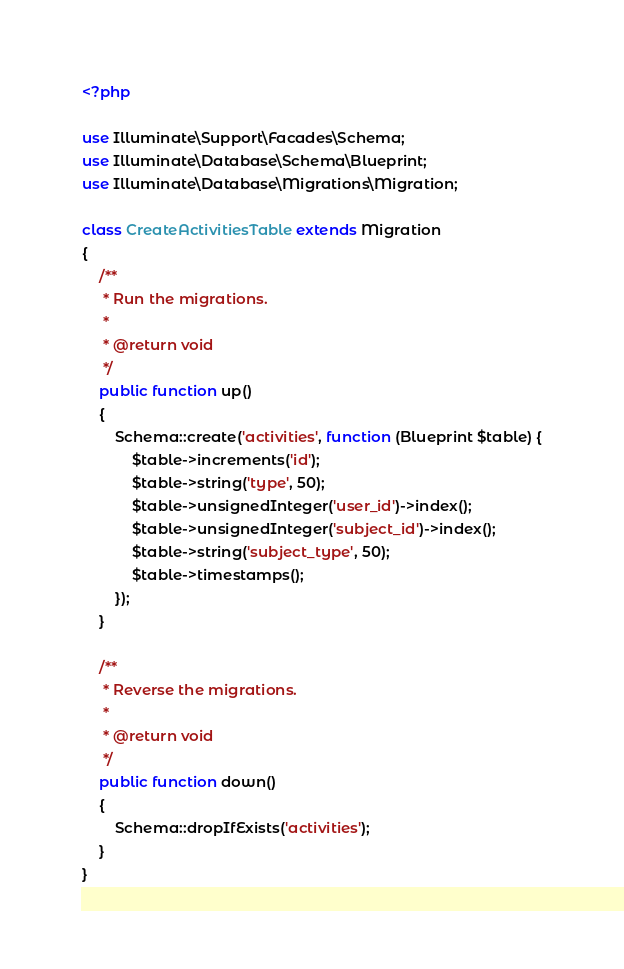<code> <loc_0><loc_0><loc_500><loc_500><_PHP_><?php

use Illuminate\Support\Facades\Schema;
use Illuminate\Database\Schema\Blueprint;
use Illuminate\Database\Migrations\Migration;

class CreateActivitiesTable extends Migration
{
    /**
     * Run the migrations.
     *
     * @return void
     */
    public function up()
    {
        Schema::create('activities', function (Blueprint $table) {
            $table->increments('id');
            $table->string('type', 50);
            $table->unsignedInteger('user_id')->index();
            $table->unsignedInteger('subject_id')->index();
            $table->string('subject_type', 50);
            $table->timestamps();
        });
    }

    /**
     * Reverse the migrations.
     *
     * @return void
     */
    public function down()
    {
        Schema::dropIfExists('activities');
    }
}
</code> 